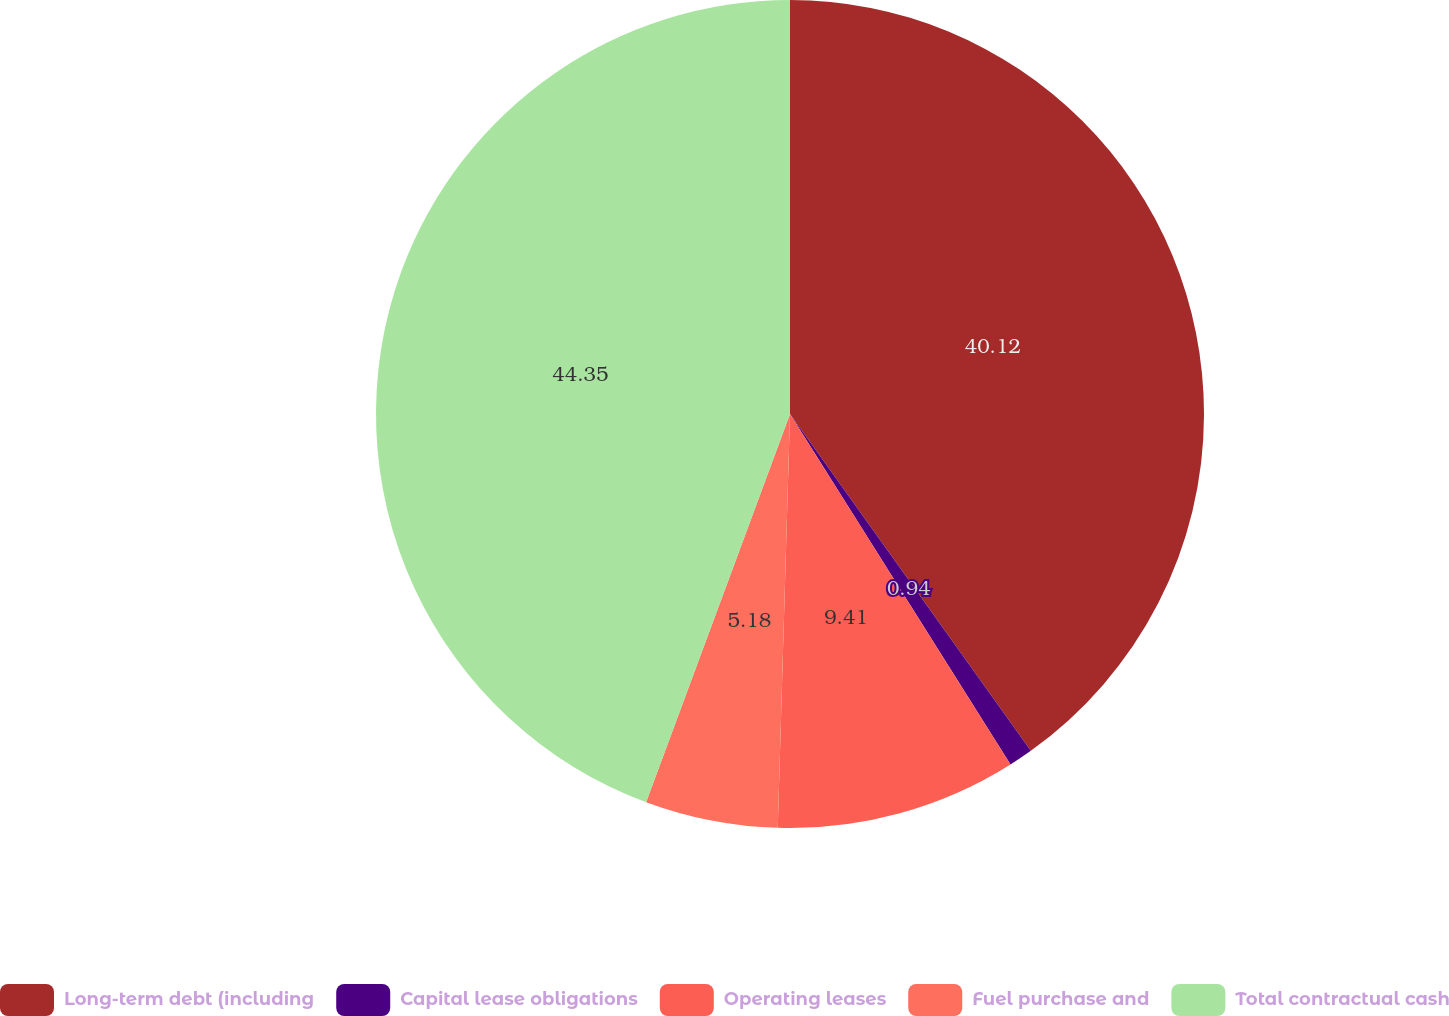<chart> <loc_0><loc_0><loc_500><loc_500><pie_chart><fcel>Long-term debt (including<fcel>Capital lease obligations<fcel>Operating leases<fcel>Fuel purchase and<fcel>Total contractual cash<nl><fcel>40.12%<fcel>0.94%<fcel>9.41%<fcel>5.18%<fcel>44.35%<nl></chart> 